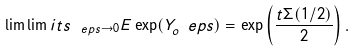<formula> <loc_0><loc_0><loc_500><loc_500>\lim \lim i t s _ { \ e p s \to 0 } E \exp ( Y _ { o } ^ { \ } e p s ) = \exp \left ( \frac { t \Sigma ( 1 / 2 ) } { 2 } \right ) .</formula> 